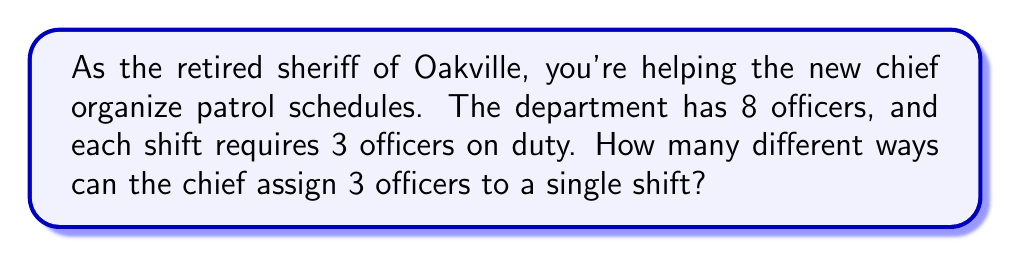Show me your answer to this math problem. Let's approach this step-by-step:

1) This is a combination problem. We're selecting 3 officers from a total of 8, where the order doesn't matter (it's not important who is first, second, or third on the shift).

2) The formula for combinations is:

   $$C(n,r) = \frac{n!}{r!(n-r)!}$$

   Where $n$ is the total number of items to choose from, and $r$ is the number of items being chosen.

3) In this case, $n = 8$ (total officers) and $r = 3$ (officers per shift).

4) Plugging these numbers into our formula:

   $$C(8,3) = \frac{8!}{3!(8-3)!} = \frac{8!}{3!5!}$$

5) Expand this:
   $$\frac{8 * 7 * 6 * 5!}{(3 * 2 * 1) * 5!}$$

6) The 5! cancels out in the numerator and denominator:
   $$\frac{8 * 7 * 6}{3 * 2 * 1} = \frac{336}{6} = 56$$

Therefore, there are 56 different ways to assign 3 officers to a single shift.
Answer: 56 different combinations 